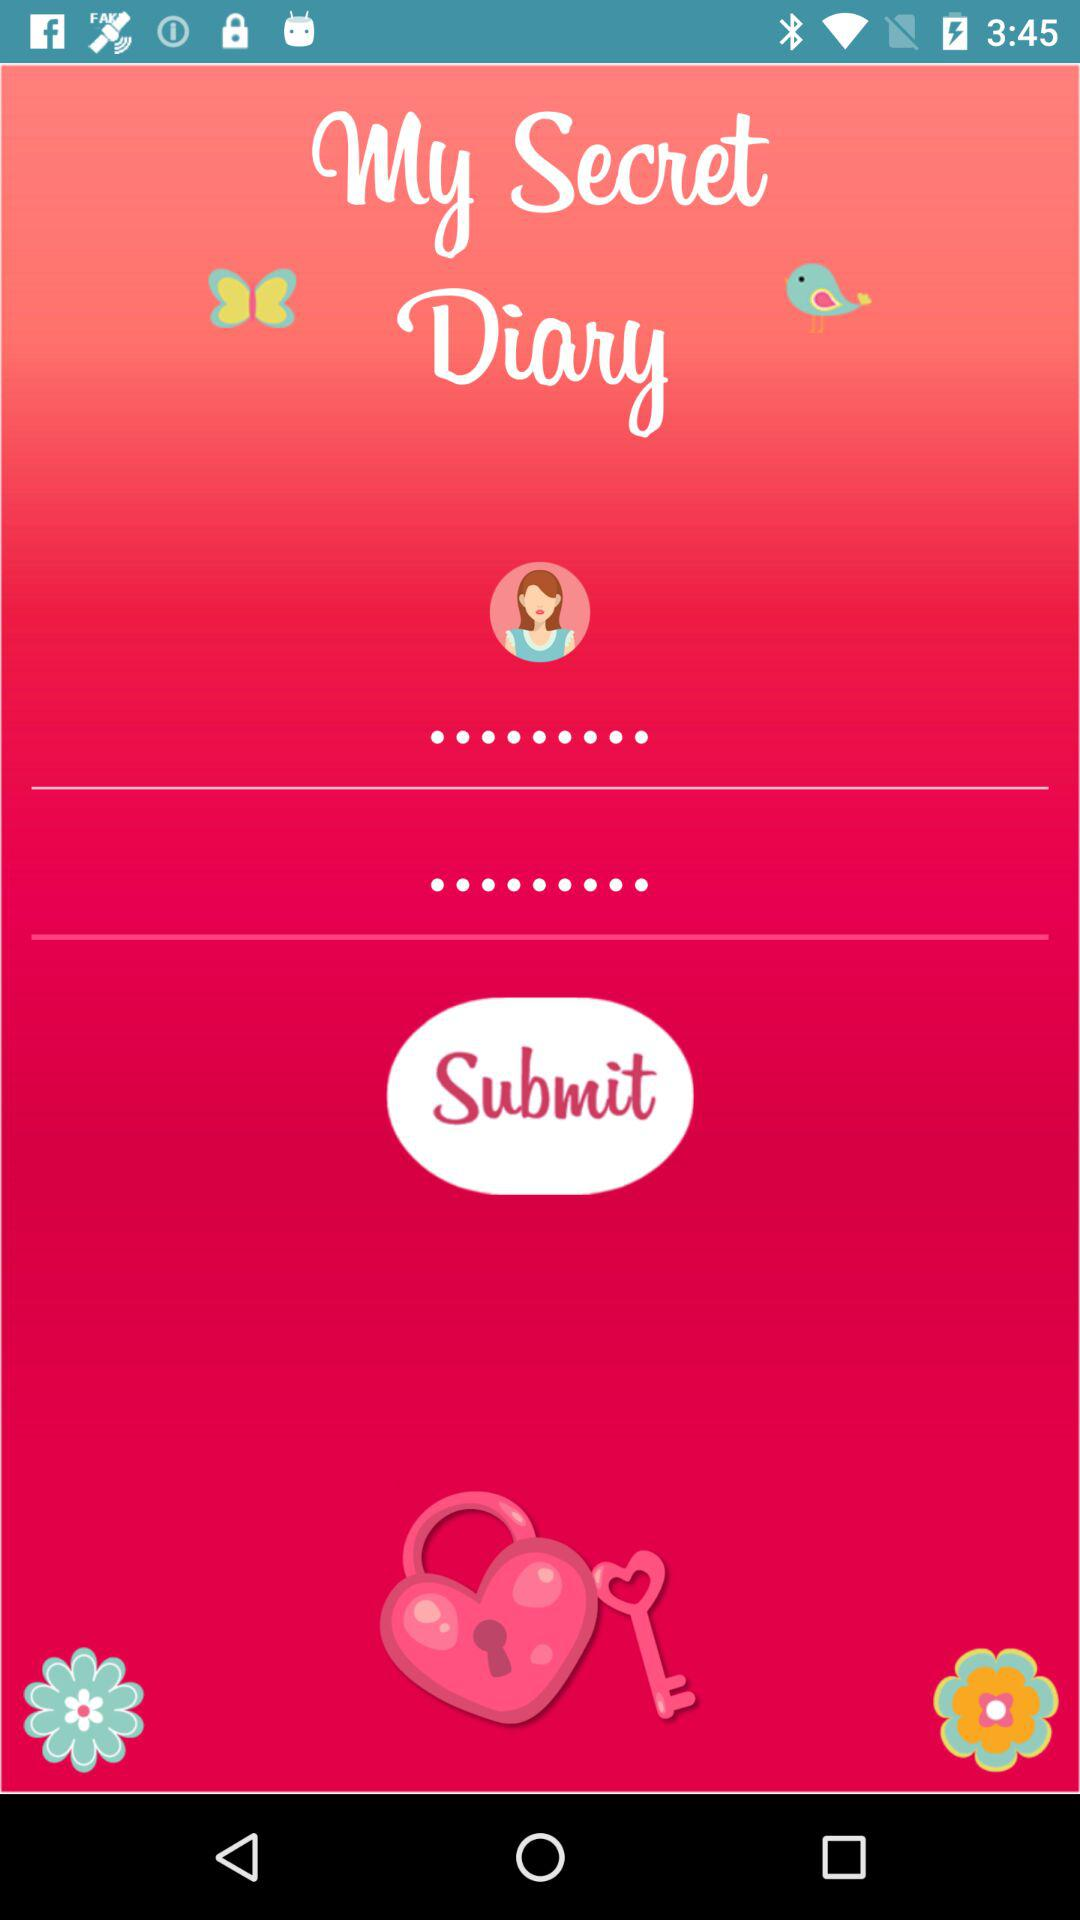What is the application name? The application name is "My Secret Diary". 